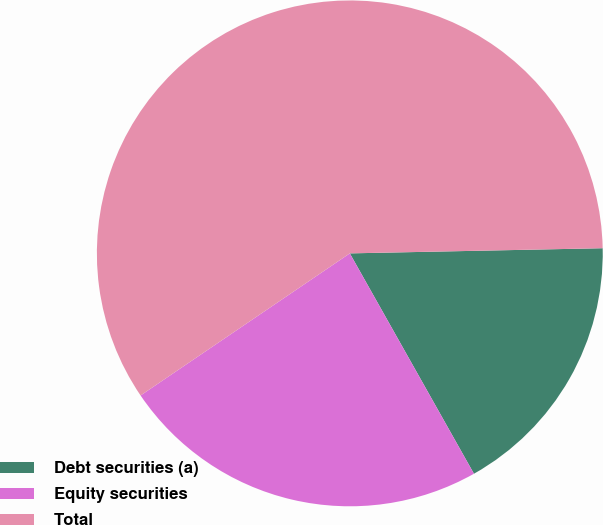Convert chart to OTSL. <chart><loc_0><loc_0><loc_500><loc_500><pie_chart><fcel>Debt securities (a)<fcel>Equity securities<fcel>Total<nl><fcel>17.16%<fcel>23.67%<fcel>59.17%<nl></chart> 